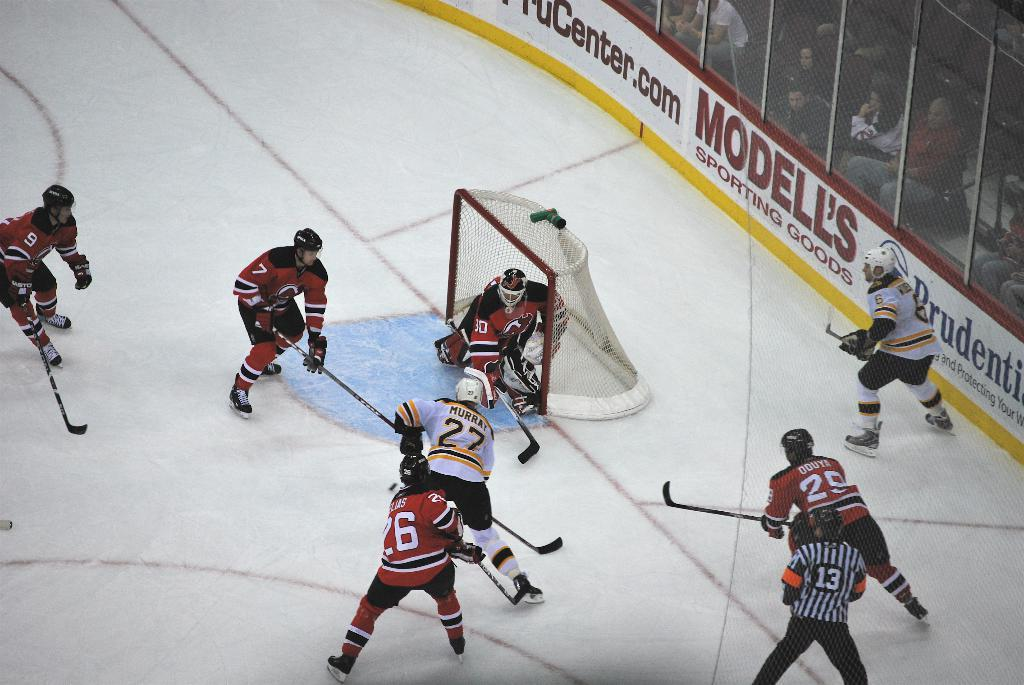<image>
Present a compact description of the photo's key features. hockey players on the ice playing in front of ads for Modell's 